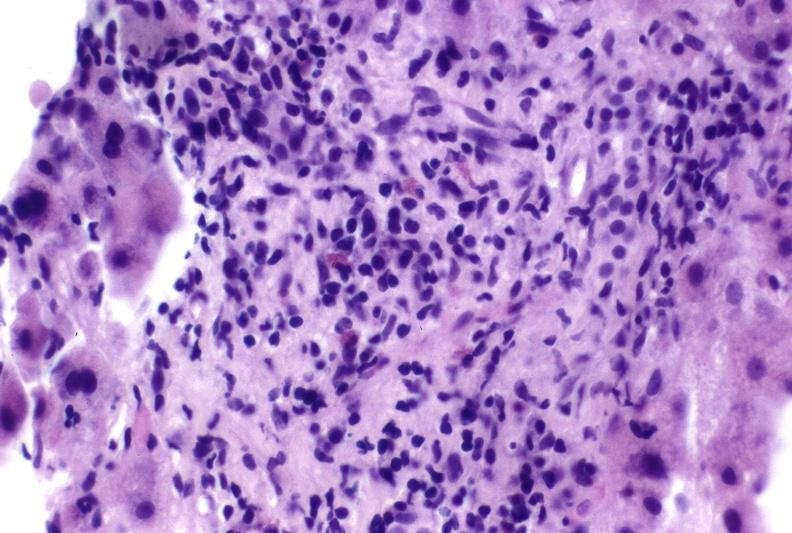what is present?
Answer the question using a single word or phrase. Liver 